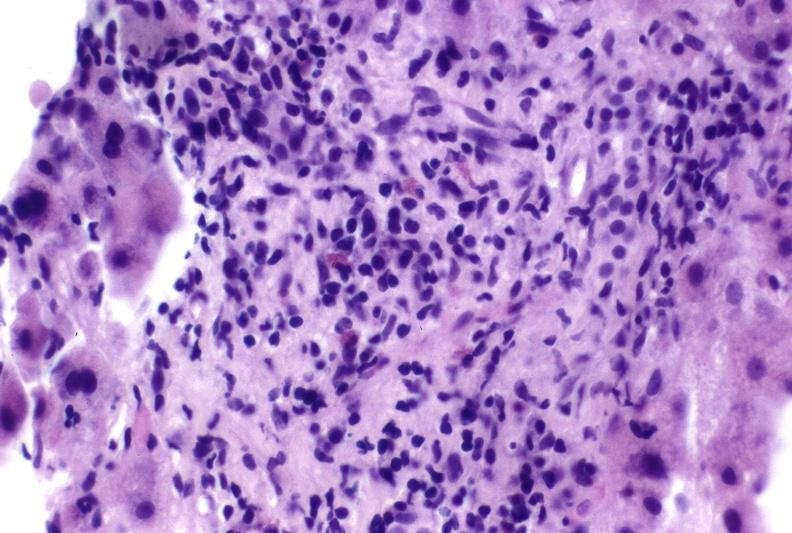what is present?
Answer the question using a single word or phrase. Liver 